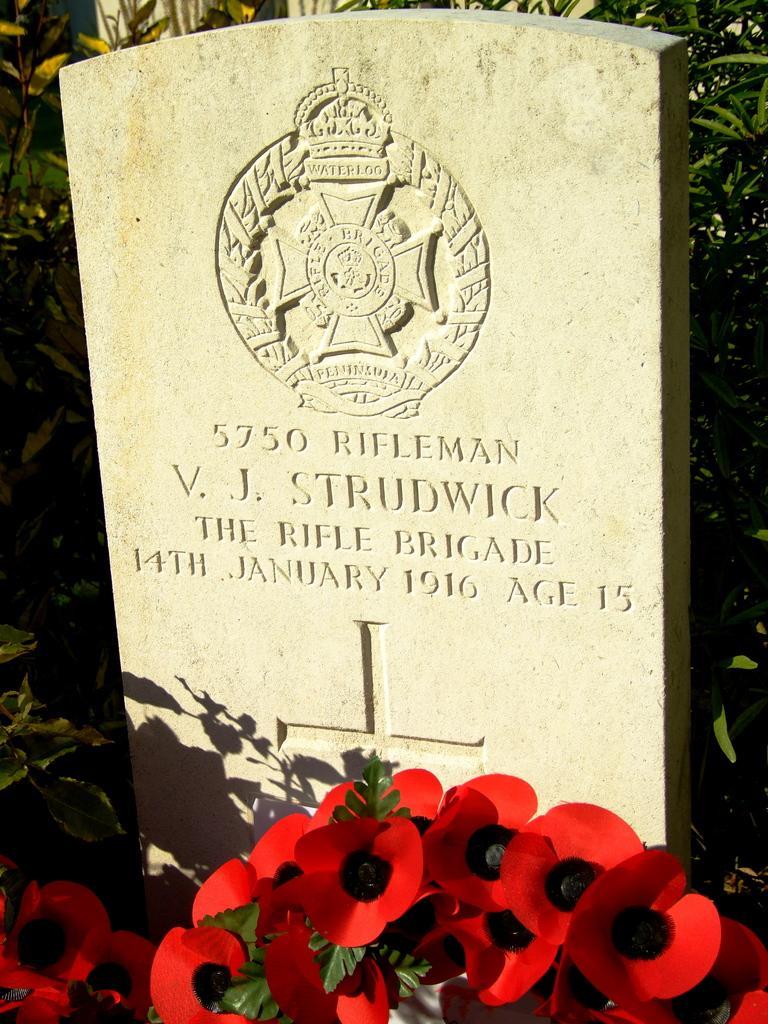Could you give a brief overview of what you see in this image? In this picture we can see some text and carvings on a grave. There are a few red flowers in front of the grave. We can see some green plants in the background. 